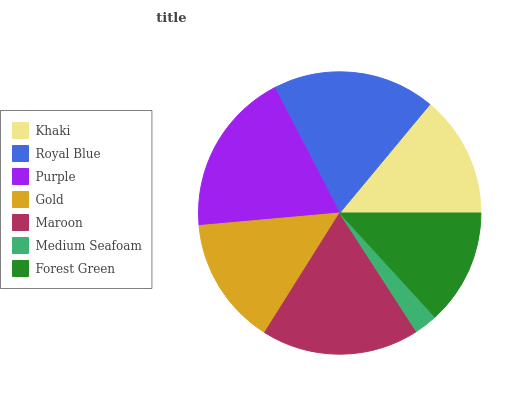Is Medium Seafoam the minimum?
Answer yes or no. Yes. Is Purple the maximum?
Answer yes or no. Yes. Is Royal Blue the minimum?
Answer yes or no. No. Is Royal Blue the maximum?
Answer yes or no. No. Is Royal Blue greater than Khaki?
Answer yes or no. Yes. Is Khaki less than Royal Blue?
Answer yes or no. Yes. Is Khaki greater than Royal Blue?
Answer yes or no. No. Is Royal Blue less than Khaki?
Answer yes or no. No. Is Gold the high median?
Answer yes or no. Yes. Is Gold the low median?
Answer yes or no. Yes. Is Forest Green the high median?
Answer yes or no. No. Is Khaki the low median?
Answer yes or no. No. 